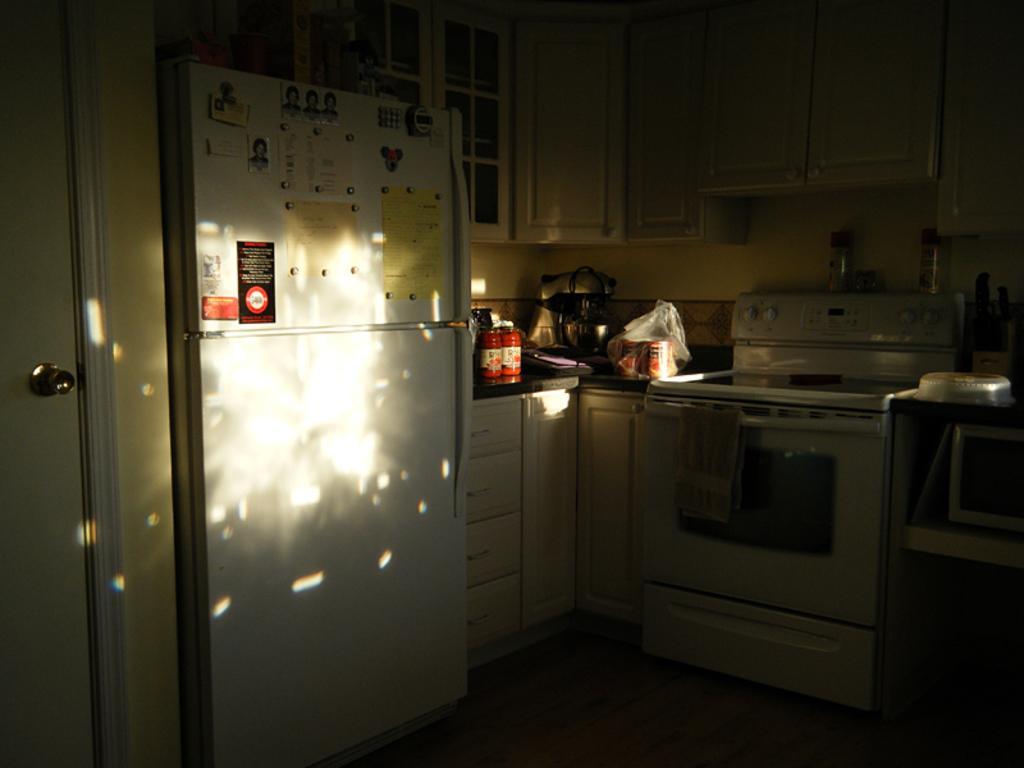Describe this image in one or two sentences. In this image we can see there is a refrigerator. There are cupboards. There is a stove. There are objects on the platform. There is a door. 